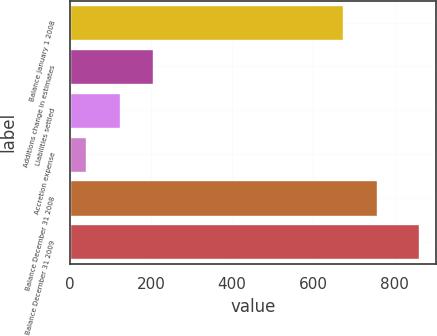<chart> <loc_0><loc_0><loc_500><loc_500><bar_chart><fcel>Balance January 1 2008<fcel>Additions change in estimates<fcel>Liabilities settled<fcel>Accretion expense<fcel>Balance December 31 2008<fcel>Balance December 31 2009<nl><fcel>672<fcel>204.6<fcel>122.8<fcel>41<fcel>757<fcel>859<nl></chart> 